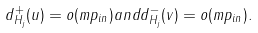<formula> <loc_0><loc_0><loc_500><loc_500>d ^ { + } _ { H _ { j } } ( u ) = o ( m p _ { i n } ) a n d d ^ { - } _ { H _ { j } } ( v ) = o ( m p _ { i n } ) .</formula> 